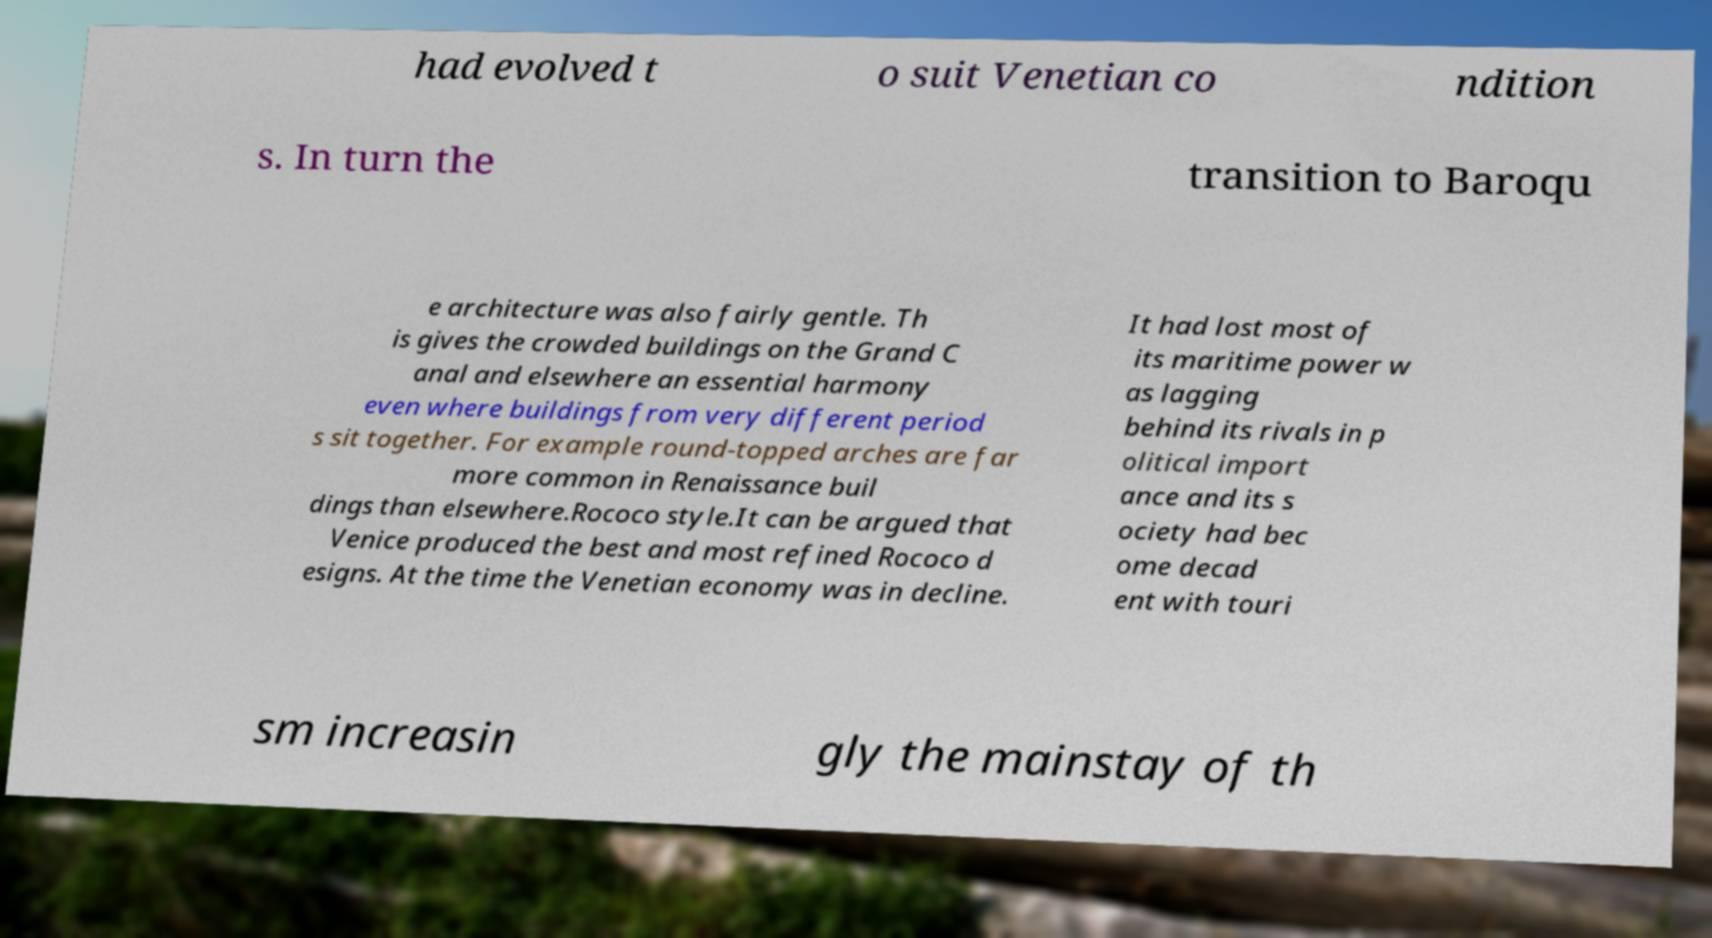What messages or text are displayed in this image? I need them in a readable, typed format. had evolved t o suit Venetian co ndition s. In turn the transition to Baroqu e architecture was also fairly gentle. Th is gives the crowded buildings on the Grand C anal and elsewhere an essential harmony even where buildings from very different period s sit together. For example round-topped arches are far more common in Renaissance buil dings than elsewhere.Rococo style.It can be argued that Venice produced the best and most refined Rococo d esigns. At the time the Venetian economy was in decline. It had lost most of its maritime power w as lagging behind its rivals in p olitical import ance and its s ociety had bec ome decad ent with touri sm increasin gly the mainstay of th 